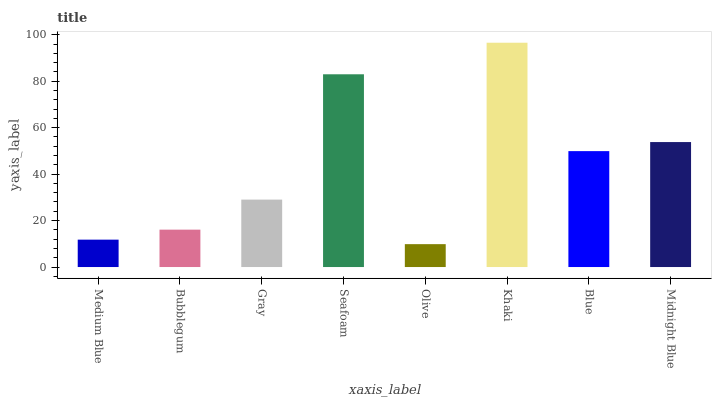Is Olive the minimum?
Answer yes or no. Yes. Is Khaki the maximum?
Answer yes or no. Yes. Is Bubblegum the minimum?
Answer yes or no. No. Is Bubblegum the maximum?
Answer yes or no. No. Is Bubblegum greater than Medium Blue?
Answer yes or no. Yes. Is Medium Blue less than Bubblegum?
Answer yes or no. Yes. Is Medium Blue greater than Bubblegum?
Answer yes or no. No. Is Bubblegum less than Medium Blue?
Answer yes or no. No. Is Blue the high median?
Answer yes or no. Yes. Is Gray the low median?
Answer yes or no. Yes. Is Khaki the high median?
Answer yes or no. No. Is Khaki the low median?
Answer yes or no. No. 